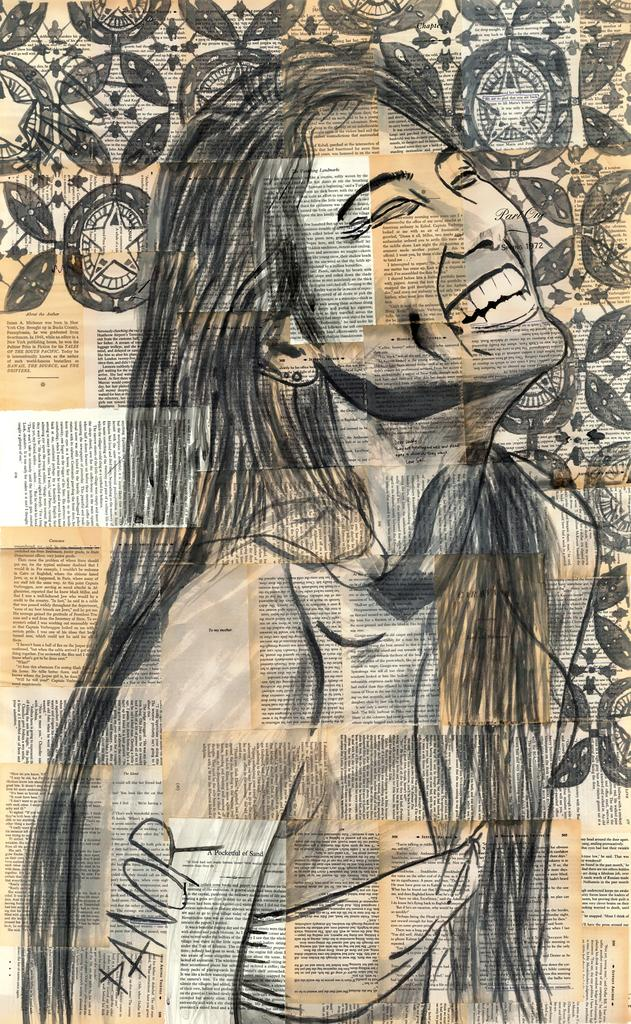<image>
Offer a succinct explanation of the picture presented. A drawing of a woman on top of a collage of printed papers with PANOR written in the corner. 